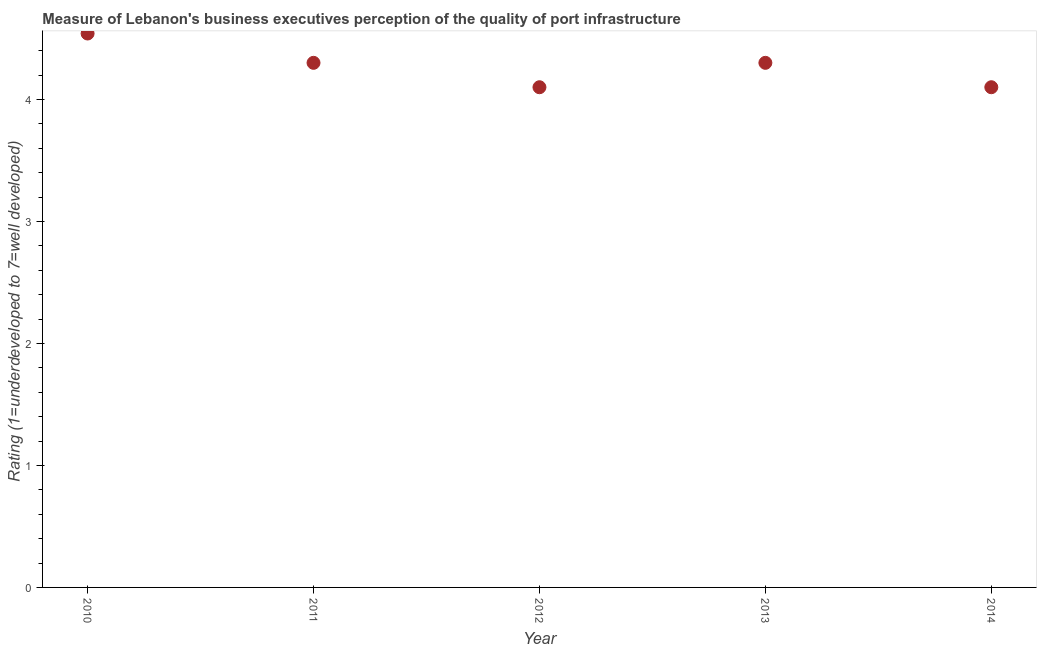Across all years, what is the maximum rating measuring quality of port infrastructure?
Keep it short and to the point. 4.54. In which year was the rating measuring quality of port infrastructure minimum?
Provide a short and direct response. 2012. What is the sum of the rating measuring quality of port infrastructure?
Offer a terse response. 21.34. What is the difference between the rating measuring quality of port infrastructure in 2012 and 2013?
Give a very brief answer. -0.2. What is the average rating measuring quality of port infrastructure per year?
Your answer should be compact. 4.27. In how many years, is the rating measuring quality of port infrastructure greater than 3.8 ?
Give a very brief answer. 5. What is the ratio of the rating measuring quality of port infrastructure in 2013 to that in 2014?
Make the answer very short. 1.05. Is the rating measuring quality of port infrastructure in 2012 less than that in 2013?
Offer a terse response. Yes. Is the difference between the rating measuring quality of port infrastructure in 2010 and 2011 greater than the difference between any two years?
Your response must be concise. No. What is the difference between the highest and the second highest rating measuring quality of port infrastructure?
Provide a short and direct response. 0.24. What is the difference between the highest and the lowest rating measuring quality of port infrastructure?
Your answer should be very brief. 0.44. Does the graph contain any zero values?
Ensure brevity in your answer.  No. Does the graph contain grids?
Provide a short and direct response. No. What is the title of the graph?
Your answer should be very brief. Measure of Lebanon's business executives perception of the quality of port infrastructure. What is the label or title of the X-axis?
Provide a succinct answer. Year. What is the label or title of the Y-axis?
Offer a terse response. Rating (1=underdeveloped to 7=well developed) . What is the Rating (1=underdeveloped to 7=well developed)  in 2010?
Keep it short and to the point. 4.54. What is the Rating (1=underdeveloped to 7=well developed)  in 2011?
Keep it short and to the point. 4.3. What is the Rating (1=underdeveloped to 7=well developed)  in 2012?
Ensure brevity in your answer.  4.1. What is the Rating (1=underdeveloped to 7=well developed)  in 2014?
Offer a terse response. 4.1. What is the difference between the Rating (1=underdeveloped to 7=well developed)  in 2010 and 2011?
Provide a short and direct response. 0.24. What is the difference between the Rating (1=underdeveloped to 7=well developed)  in 2010 and 2012?
Your answer should be very brief. 0.44. What is the difference between the Rating (1=underdeveloped to 7=well developed)  in 2010 and 2013?
Provide a succinct answer. 0.24. What is the difference between the Rating (1=underdeveloped to 7=well developed)  in 2010 and 2014?
Your answer should be very brief. 0.44. What is the difference between the Rating (1=underdeveloped to 7=well developed)  in 2012 and 2014?
Make the answer very short. 0. What is the ratio of the Rating (1=underdeveloped to 7=well developed)  in 2010 to that in 2011?
Make the answer very short. 1.06. What is the ratio of the Rating (1=underdeveloped to 7=well developed)  in 2010 to that in 2012?
Keep it short and to the point. 1.11. What is the ratio of the Rating (1=underdeveloped to 7=well developed)  in 2010 to that in 2013?
Provide a short and direct response. 1.06. What is the ratio of the Rating (1=underdeveloped to 7=well developed)  in 2010 to that in 2014?
Make the answer very short. 1.11. What is the ratio of the Rating (1=underdeveloped to 7=well developed)  in 2011 to that in 2012?
Provide a short and direct response. 1.05. What is the ratio of the Rating (1=underdeveloped to 7=well developed)  in 2011 to that in 2013?
Your response must be concise. 1. What is the ratio of the Rating (1=underdeveloped to 7=well developed)  in 2011 to that in 2014?
Offer a terse response. 1.05. What is the ratio of the Rating (1=underdeveloped to 7=well developed)  in 2012 to that in 2013?
Your answer should be very brief. 0.95. What is the ratio of the Rating (1=underdeveloped to 7=well developed)  in 2012 to that in 2014?
Make the answer very short. 1. What is the ratio of the Rating (1=underdeveloped to 7=well developed)  in 2013 to that in 2014?
Offer a terse response. 1.05. 